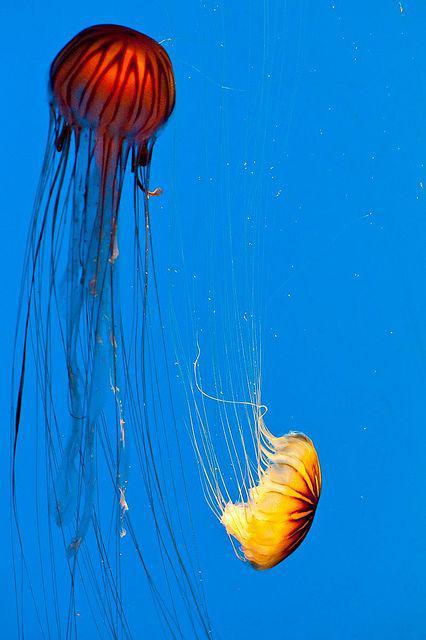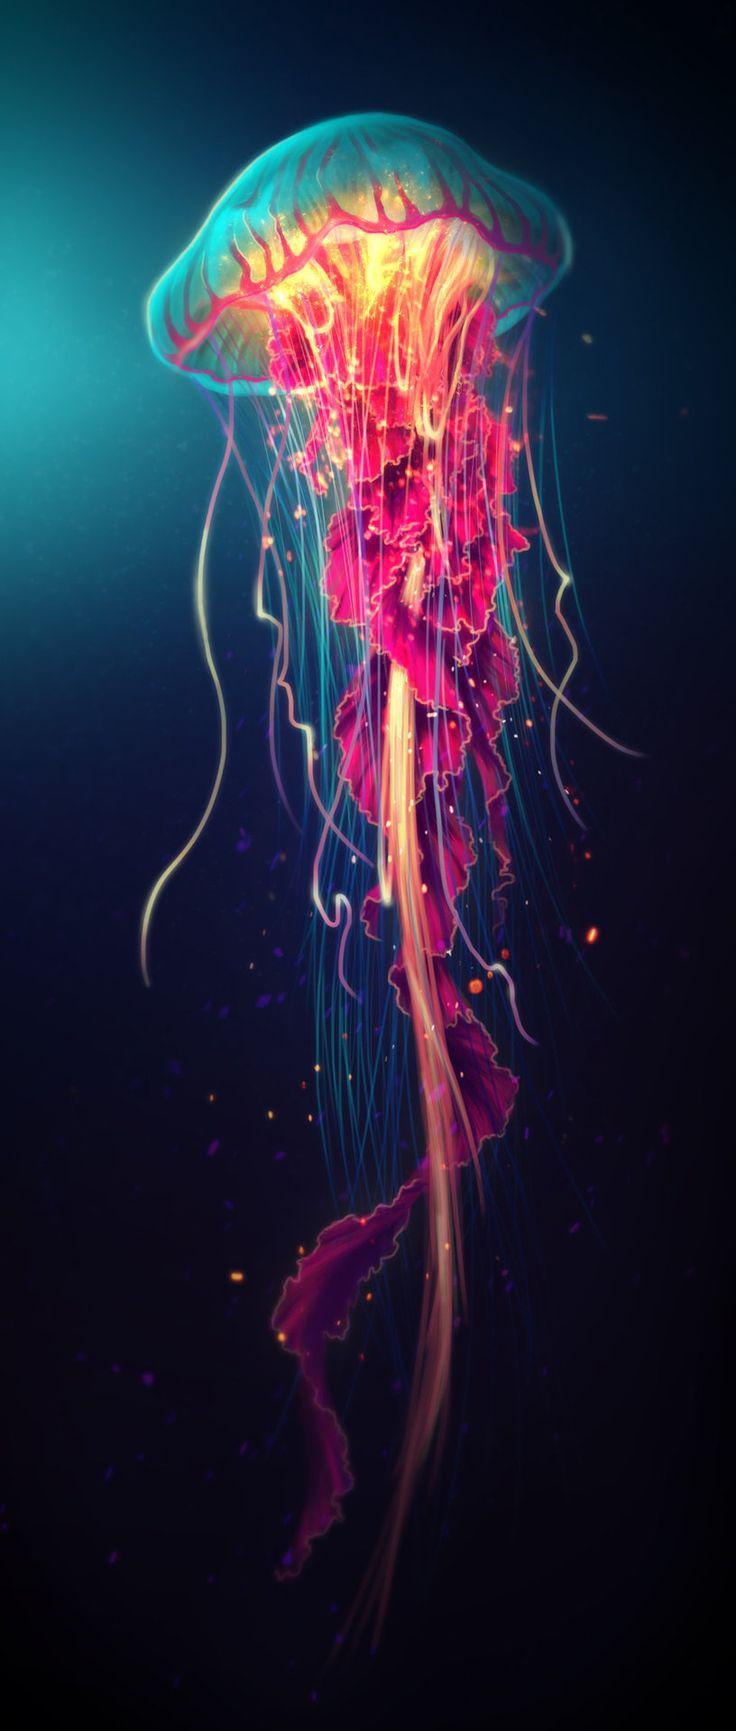The first image is the image on the left, the second image is the image on the right. Considering the images on both sides, is "Two jellyfish are visible in the left image." valid? Answer yes or no. Yes. 